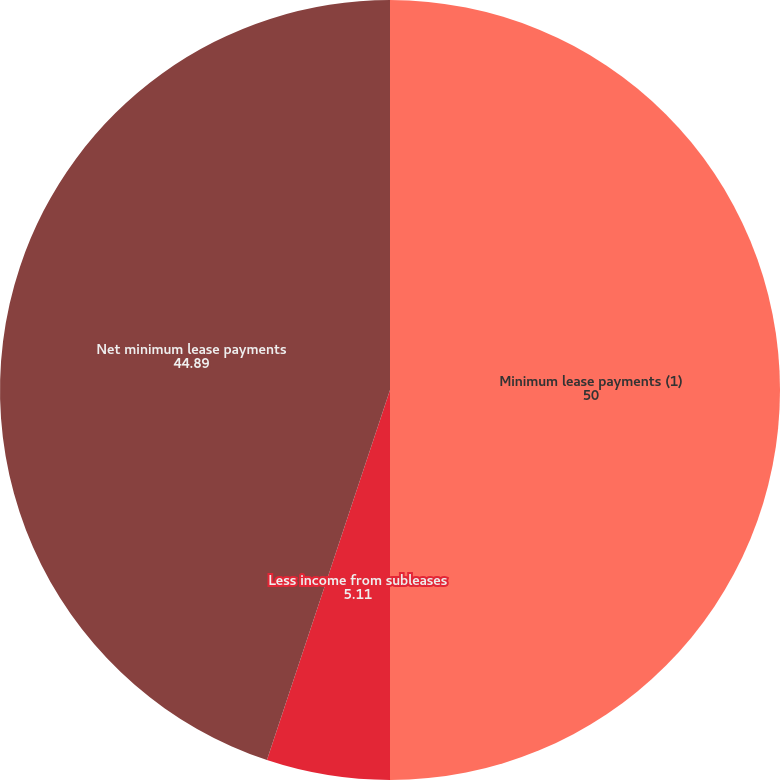Convert chart to OTSL. <chart><loc_0><loc_0><loc_500><loc_500><pie_chart><fcel>Minimum lease payments (1)<fcel>Less income from subleases<fcel>Net minimum lease payments<nl><fcel>50.0%<fcel>5.11%<fcel>44.89%<nl></chart> 